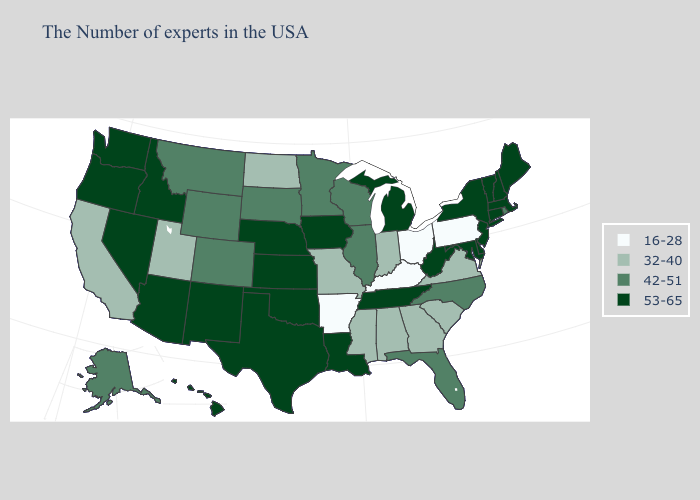Does the first symbol in the legend represent the smallest category?
Concise answer only. Yes. Name the states that have a value in the range 42-51?
Short answer required. Rhode Island, North Carolina, Florida, Wisconsin, Illinois, Minnesota, South Dakota, Wyoming, Colorado, Montana, Alaska. Does Texas have a higher value than Washington?
Answer briefly. No. Does Kansas have the highest value in the MidWest?
Be succinct. Yes. Does Nevada have the highest value in the USA?
Quick response, please. Yes. What is the value of Utah?
Quick response, please. 32-40. Name the states that have a value in the range 42-51?
Quick response, please. Rhode Island, North Carolina, Florida, Wisconsin, Illinois, Minnesota, South Dakota, Wyoming, Colorado, Montana, Alaska. What is the lowest value in the USA?
Keep it brief. 16-28. Among the states that border North Carolina , does South Carolina have the lowest value?
Quick response, please. Yes. Does South Dakota have a lower value than Florida?
Answer briefly. No. Does Louisiana have the same value as Arkansas?
Keep it brief. No. Among the states that border Arizona , which have the lowest value?
Keep it brief. Utah, California. What is the lowest value in the Northeast?
Short answer required. 16-28. Name the states that have a value in the range 32-40?
Quick response, please. Virginia, South Carolina, Georgia, Indiana, Alabama, Mississippi, Missouri, North Dakota, Utah, California. Does Texas have the same value as Florida?
Concise answer only. No. 